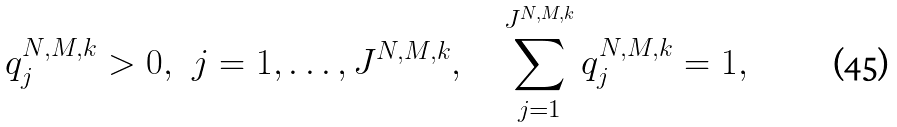Convert formula to latex. <formula><loc_0><loc_0><loc_500><loc_500>\ q _ { j } ^ { N , M , k } > 0 , \ \ j = 1 , \dots , J ^ { N , M , k } , \quad \sum _ { j = 1 } ^ { J ^ { N , M , k } } q _ { j } ^ { N , M , k } = 1 ,</formula> 